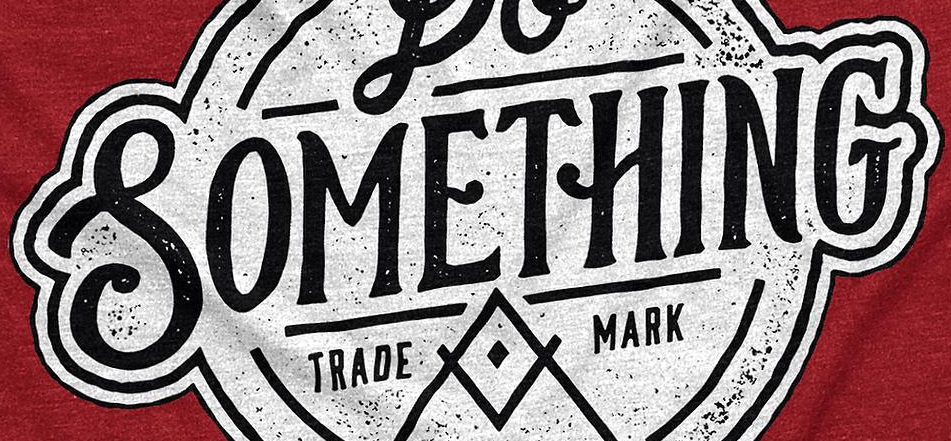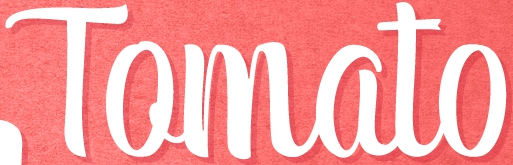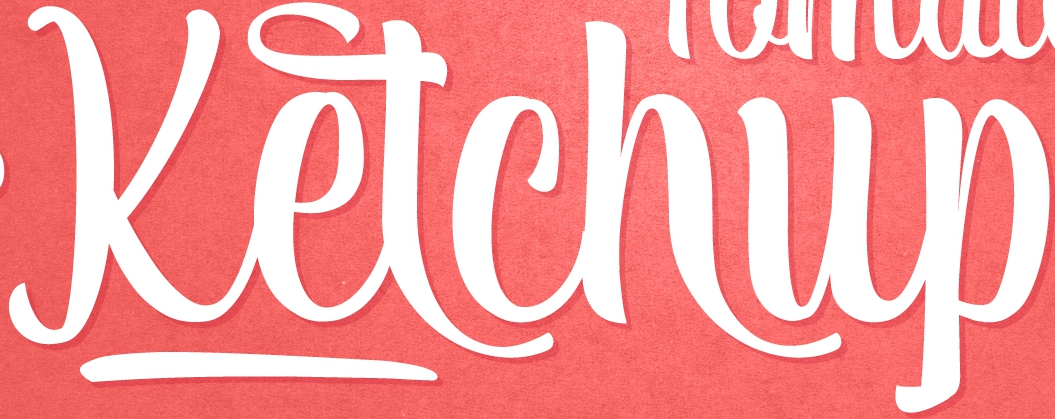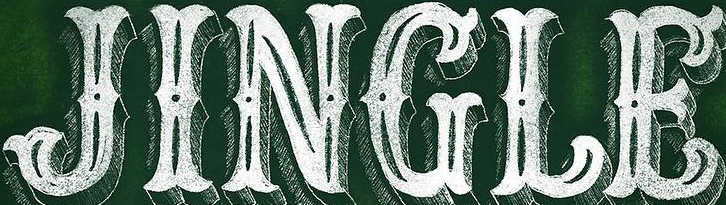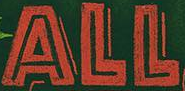Read the text from these images in sequence, separated by a semicolon. SOMETHING; Tomato; Ketchup; JINGLE; ALL 